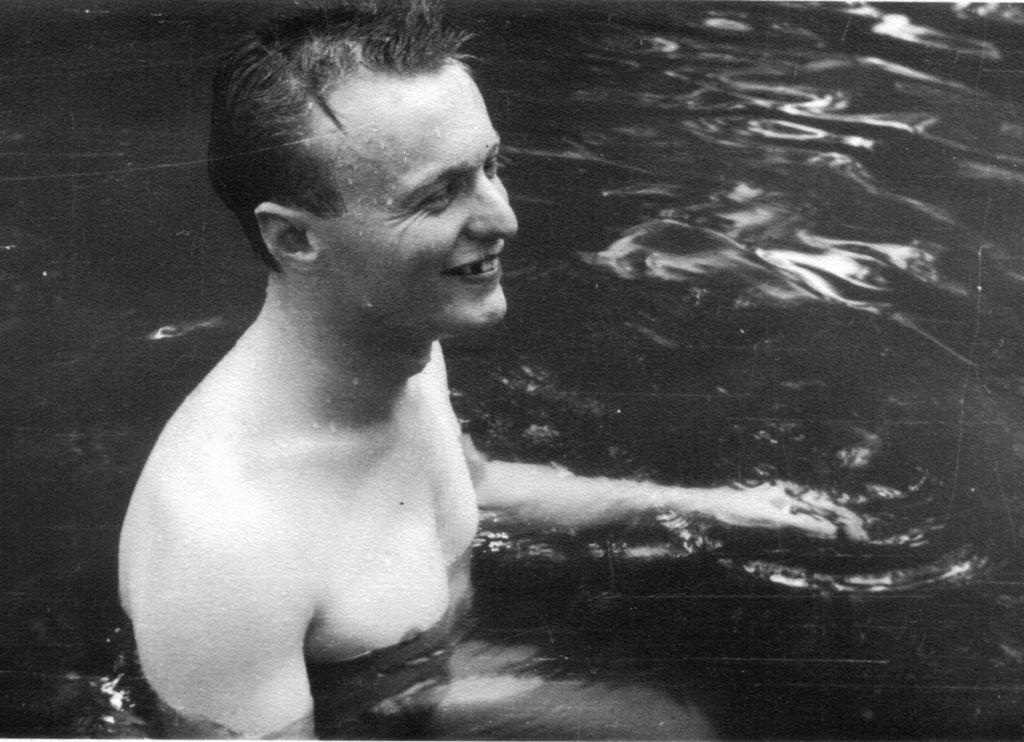Please provide a concise description of this image. In the image there is a man in the water. And he is smiling. 